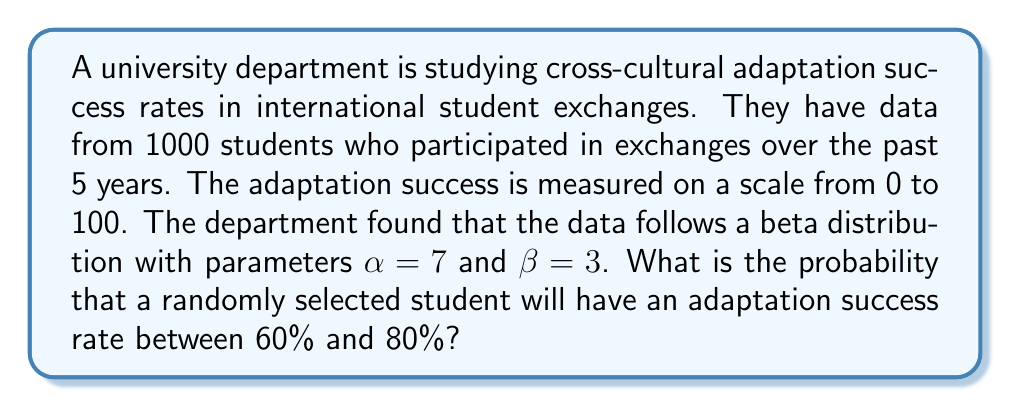Teach me how to tackle this problem. To solve this problem, we need to use the cumulative distribution function (CDF) of the beta distribution. The steps are as follows:

1) The beta distribution with parameters $\alpha = 7$ and $\beta = 3$ has the probability density function:

   $$f(x) = \frac{x^{6}(1-x)^{2}}{B(7,3)}$$

   where $B(7,3)$ is the beta function.

2) We need to find $P(0.60 \leq X \leq 0.80)$, which is equivalent to $F(0.80) - F(0.60)$, where $F(x)$ is the CDF of the beta distribution.

3) The CDF of a beta distribution is given by the regularized incomplete beta function:

   $$F(x) = I_x(\alpha, \beta)$$

4) Using a statistical software or a calculator with beta distribution functions, we can calculate:

   $F(0.80) = I_{0.80}(7, 3) \approx 0.9219$
   $F(0.60) = I_{0.60}(7, 3) \approx 0.5639$

5) Therefore, the probability is:

   $$P(0.60 \leq X \leq 0.80) = F(0.80) - F(0.60) \approx 0.9219 - 0.5639 = 0.3580$$
Answer: 0.3580 